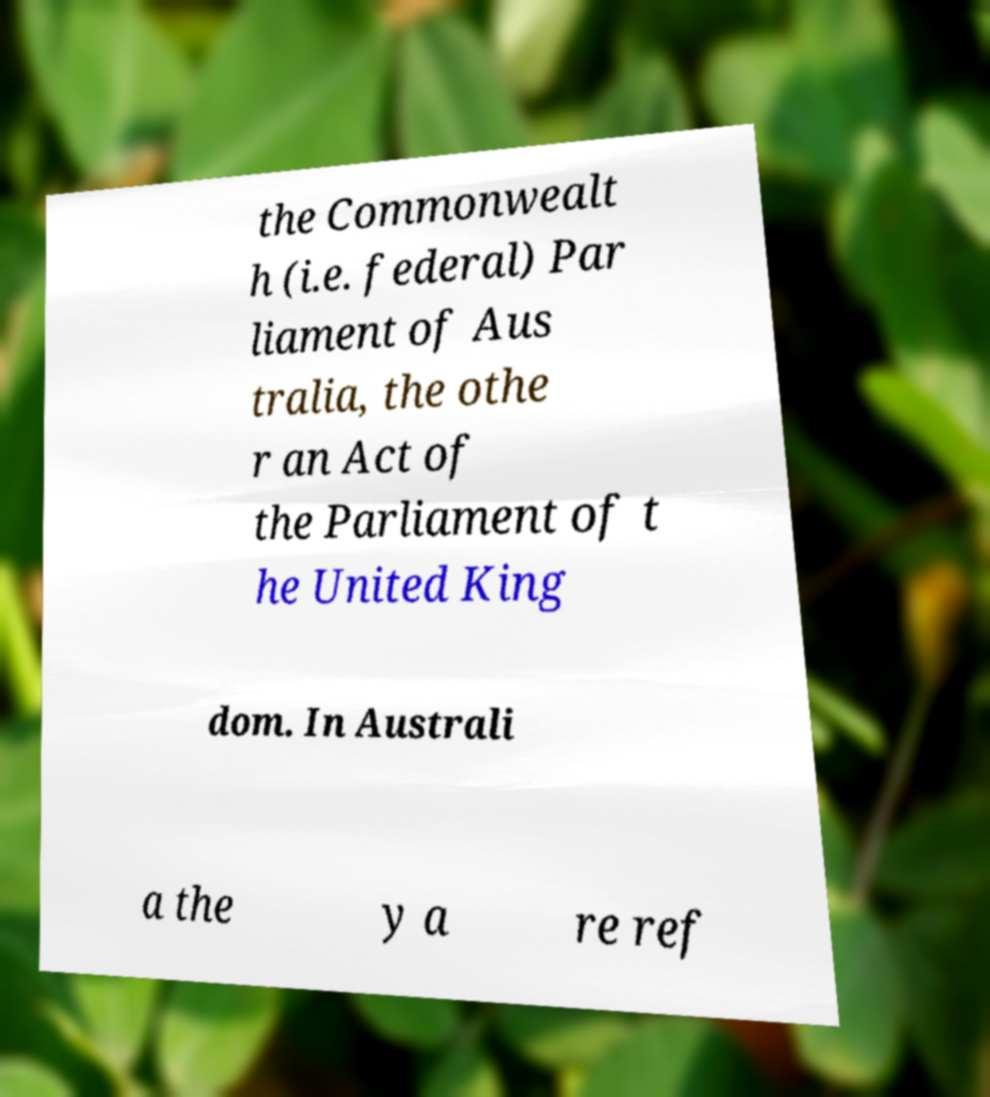Could you assist in decoding the text presented in this image and type it out clearly? the Commonwealt h (i.e. federal) Par liament of Aus tralia, the othe r an Act of the Parliament of t he United King dom. In Australi a the y a re ref 